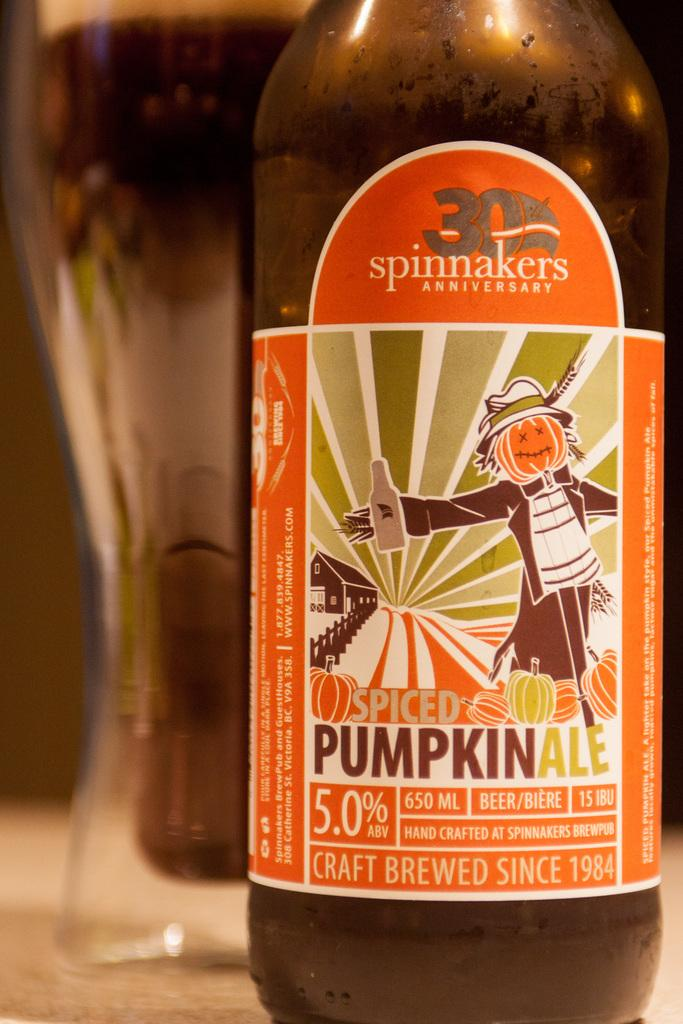<image>
Write a terse but informative summary of the picture. Spinnakers anniversary spiced pumpkin craft brewed beer is delicious in a glass. 